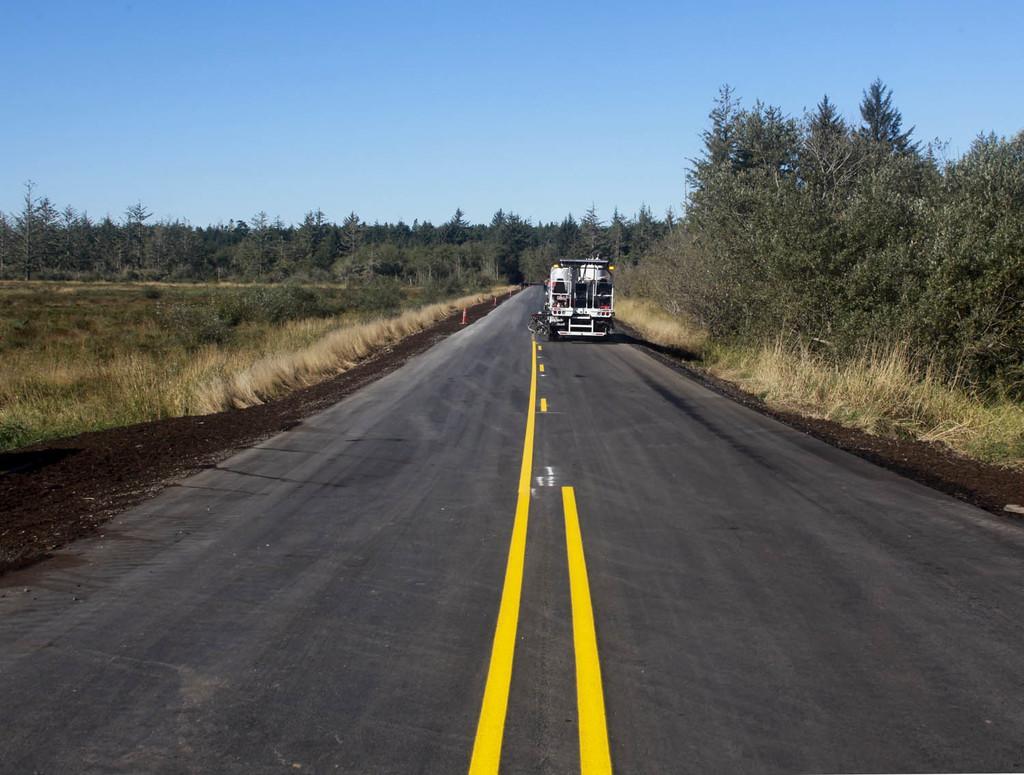Describe this image in one or two sentences. At the bottom, we see the road. In the middle, we see a vehicle in white color is moving on the road. On either side of the road, we see the soil, grass and the trees. There are trees in the background. At the top, we see the sky, which is blue in color. 